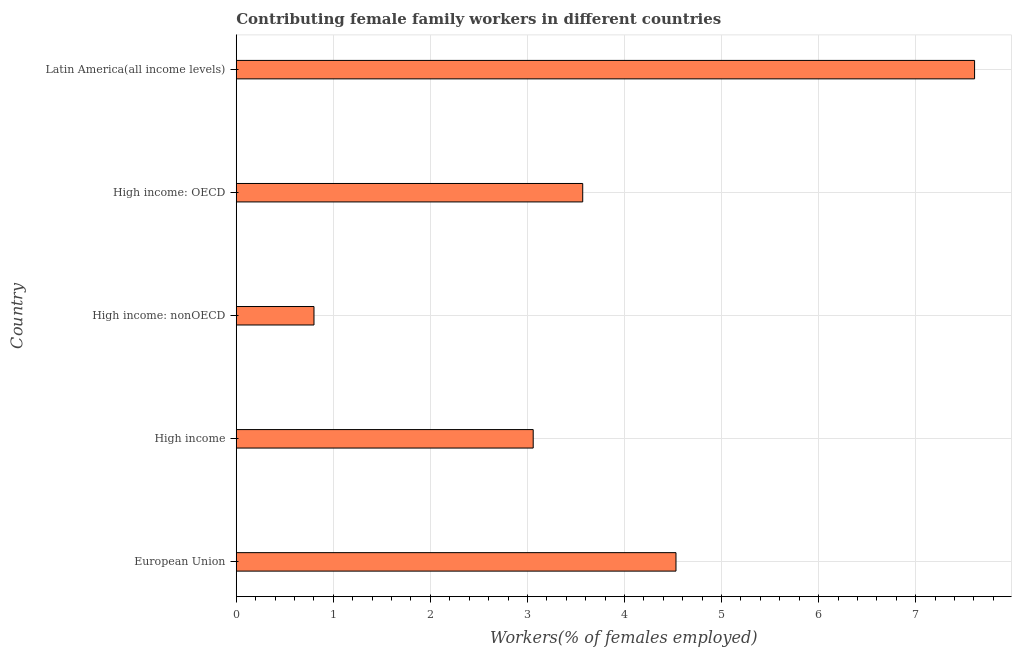What is the title of the graph?
Make the answer very short. Contributing female family workers in different countries. What is the label or title of the X-axis?
Provide a short and direct response. Workers(% of females employed). What is the label or title of the Y-axis?
Offer a terse response. Country. What is the contributing female family workers in European Union?
Offer a terse response. 4.53. Across all countries, what is the maximum contributing female family workers?
Your response must be concise. 7.61. Across all countries, what is the minimum contributing female family workers?
Your answer should be compact. 0.8. In which country was the contributing female family workers maximum?
Offer a very short reply. Latin America(all income levels). In which country was the contributing female family workers minimum?
Provide a succinct answer. High income: nonOECD. What is the sum of the contributing female family workers?
Your answer should be compact. 19.57. What is the difference between the contributing female family workers in High income and High income: nonOECD?
Your response must be concise. 2.26. What is the average contributing female family workers per country?
Provide a succinct answer. 3.91. What is the median contributing female family workers?
Provide a short and direct response. 3.57. In how many countries, is the contributing female family workers greater than 0.4 %?
Provide a succinct answer. 5. What is the ratio of the contributing female family workers in High income: nonOECD to that in Latin America(all income levels)?
Ensure brevity in your answer.  0.1. Is the difference between the contributing female family workers in European Union and High income: OECD greater than the difference between any two countries?
Your answer should be compact. No. What is the difference between the highest and the second highest contributing female family workers?
Make the answer very short. 3.08. Is the sum of the contributing female family workers in High income and Latin America(all income levels) greater than the maximum contributing female family workers across all countries?
Your answer should be very brief. Yes. What is the difference between the highest and the lowest contributing female family workers?
Your response must be concise. 6.81. In how many countries, is the contributing female family workers greater than the average contributing female family workers taken over all countries?
Your answer should be very brief. 2. How many bars are there?
Your answer should be compact. 5. How many countries are there in the graph?
Offer a terse response. 5. What is the Workers(% of females employed) of European Union?
Provide a succinct answer. 4.53. What is the Workers(% of females employed) in High income?
Provide a short and direct response. 3.06. What is the Workers(% of females employed) of High income: nonOECD?
Keep it short and to the point. 0.8. What is the Workers(% of females employed) of High income: OECD?
Make the answer very short. 3.57. What is the Workers(% of females employed) in Latin America(all income levels)?
Offer a very short reply. 7.61. What is the difference between the Workers(% of females employed) in European Union and High income?
Your response must be concise. 1.47. What is the difference between the Workers(% of females employed) in European Union and High income: nonOECD?
Offer a very short reply. 3.73. What is the difference between the Workers(% of females employed) in European Union and High income: OECD?
Give a very brief answer. 0.96. What is the difference between the Workers(% of females employed) in European Union and Latin America(all income levels)?
Your answer should be compact. -3.08. What is the difference between the Workers(% of females employed) in High income and High income: nonOECD?
Your response must be concise. 2.26. What is the difference between the Workers(% of females employed) in High income and High income: OECD?
Ensure brevity in your answer.  -0.51. What is the difference between the Workers(% of females employed) in High income and Latin America(all income levels)?
Offer a terse response. -4.55. What is the difference between the Workers(% of females employed) in High income: nonOECD and High income: OECD?
Make the answer very short. -2.77. What is the difference between the Workers(% of females employed) in High income: nonOECD and Latin America(all income levels)?
Provide a short and direct response. -6.81. What is the difference between the Workers(% of females employed) in High income: OECD and Latin America(all income levels)?
Make the answer very short. -4.04. What is the ratio of the Workers(% of females employed) in European Union to that in High income?
Offer a very short reply. 1.48. What is the ratio of the Workers(% of females employed) in European Union to that in High income: nonOECD?
Offer a very short reply. 5.66. What is the ratio of the Workers(% of females employed) in European Union to that in High income: OECD?
Keep it short and to the point. 1.27. What is the ratio of the Workers(% of females employed) in European Union to that in Latin America(all income levels)?
Ensure brevity in your answer.  0.6. What is the ratio of the Workers(% of females employed) in High income to that in High income: nonOECD?
Make the answer very short. 3.82. What is the ratio of the Workers(% of females employed) in High income to that in High income: OECD?
Your answer should be compact. 0.86. What is the ratio of the Workers(% of females employed) in High income to that in Latin America(all income levels)?
Keep it short and to the point. 0.4. What is the ratio of the Workers(% of females employed) in High income: nonOECD to that in High income: OECD?
Give a very brief answer. 0.22. What is the ratio of the Workers(% of females employed) in High income: nonOECD to that in Latin America(all income levels)?
Offer a terse response. 0.1. What is the ratio of the Workers(% of females employed) in High income: OECD to that in Latin America(all income levels)?
Your response must be concise. 0.47. 